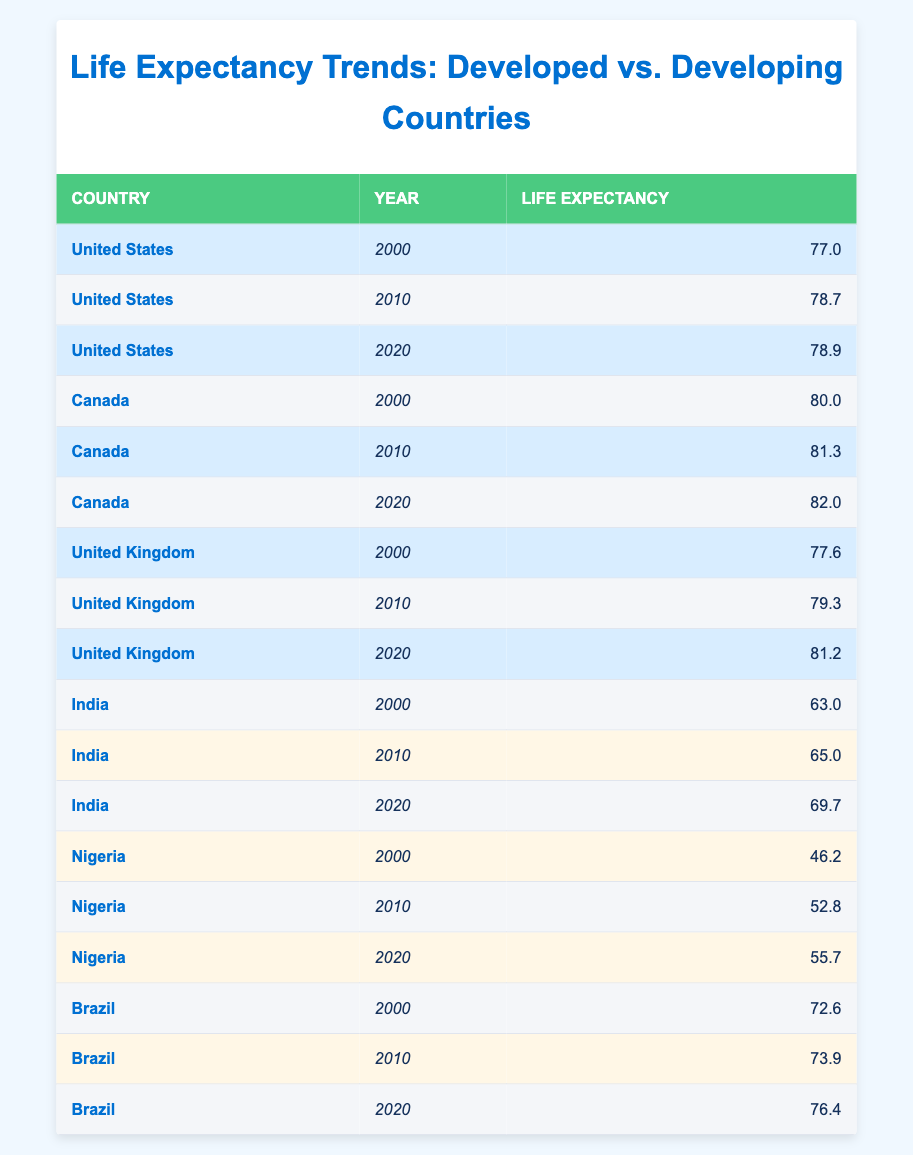What was the life expectancy in Canada in 2020? Looking at the table, under the row for Canada in the year 2020, the life expectancy value is listed as 82.0.
Answer: 82.0 What was the highest life expectancy recorded in developed countries from 2000 to 2020? The life expectancy values for developed countries are 77.0 (2000, US), 78.7 (2010, US), 78.9 (2020, US), 80.0 (2000, Canada), 81.3 (2010, Canada), 82.0 (2020, Canada), 77.6 (2000, UK), 79.3 (2010, UK), and 81.2 (2020, UK). The highest value is 82.0 in Canada in 2020.
Answer: 82.0 What is the difference in life expectancy for India between the years 2000 and 2020? The life expectancy in India in 2000 was 63.0 and in 2020 it was 69.7. The difference can be calculated as 69.7 - 63.0 = 6.7.
Answer: 6.7 Is the life expectancy in Nigeria increasing from 2000 to 2020? Yes, by comparing the values, Nigeria's life expectancy was 46.2 in 2000, 52.8 in 2010, and increased to 55.7 in 2020, indicating an upward trend.
Answer: Yes What was the average life expectancy in developed countries for the year 2010? For 2010, the life expectancy values for developed countries are 78.7 (US), 81.3 (Canada), and 79.3 (UK). To find the average, we calculate (78.7 + 81.3 + 79.3) / 3 = 79.77.
Answer: 79.77 What was the life expectancy for Brazil in 2000 compared to Nigeria in the same year? Brazil's life expectancy in 2000 was 72.6 while Nigeria's was 46.2. Comparing these values shows that Brazil had a higher life expectancy than Nigeria.
Answer: Brazil had a higher life expectancy What is the trend of life expectancy for developing countries over the years 2000 to 2020? By examining the data for developing countries, India's life expectancy rose from 63.0 to 69.7, Nigeria from 46.2 to 55.7, and Brazil from 72.6 to 76.4. Each country shows an upward trend, indicating overall improvement in life expectancy for developing countries over the period.
Answer: Upward trend How much greater was the life expectancy in Canada in 2020 compared to the United States in the same year? In 2020, Canada's life expectancy was 82.0, while the United States' was 78.9. The difference is calculated as 82.0 - 78.9 = 3.1, indicating that Canada's life expectancy was greater by 3.1 years.
Answer: 3.1 